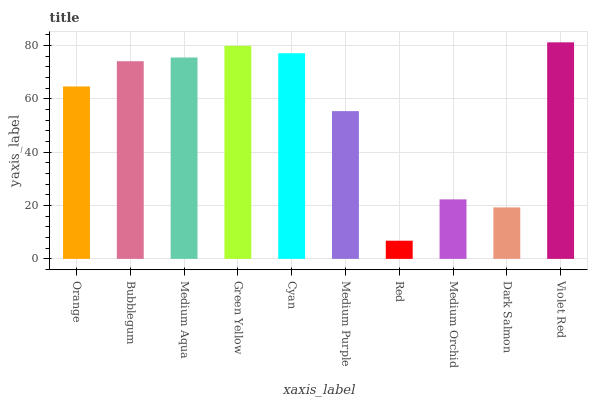Is Red the minimum?
Answer yes or no. Yes. Is Violet Red the maximum?
Answer yes or no. Yes. Is Bubblegum the minimum?
Answer yes or no. No. Is Bubblegum the maximum?
Answer yes or no. No. Is Bubblegum greater than Orange?
Answer yes or no. Yes. Is Orange less than Bubblegum?
Answer yes or no. Yes. Is Orange greater than Bubblegum?
Answer yes or no. No. Is Bubblegum less than Orange?
Answer yes or no. No. Is Bubblegum the high median?
Answer yes or no. Yes. Is Orange the low median?
Answer yes or no. Yes. Is Dark Salmon the high median?
Answer yes or no. No. Is Medium Orchid the low median?
Answer yes or no. No. 